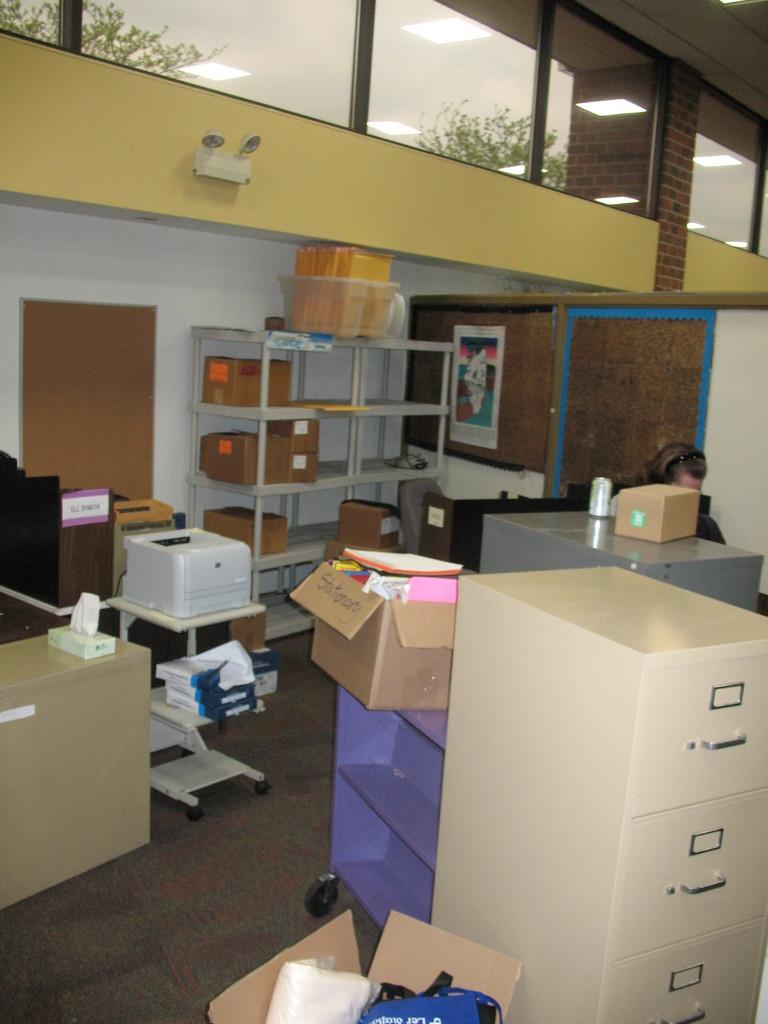How would you summarize this image in a sentence or two? In this image we can see a living room containing a cupboard, cardboard boxes, books, scanner, racks with some cardboard boxes, containing cameras, tin and a cardboard box on the table and a board. We can also see a person sitting on the floor. On the backside we can see some windows, plants and some ceiling lights. 